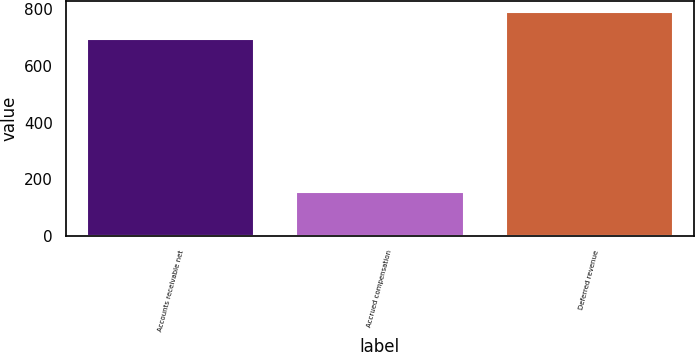Convert chart. <chart><loc_0><loc_0><loc_500><loc_500><bar_chart><fcel>Accounts receivable net<fcel>Accrued compensation<fcel>Deferred revenue<nl><fcel>693.5<fcel>157.4<fcel>790.8<nl></chart> 